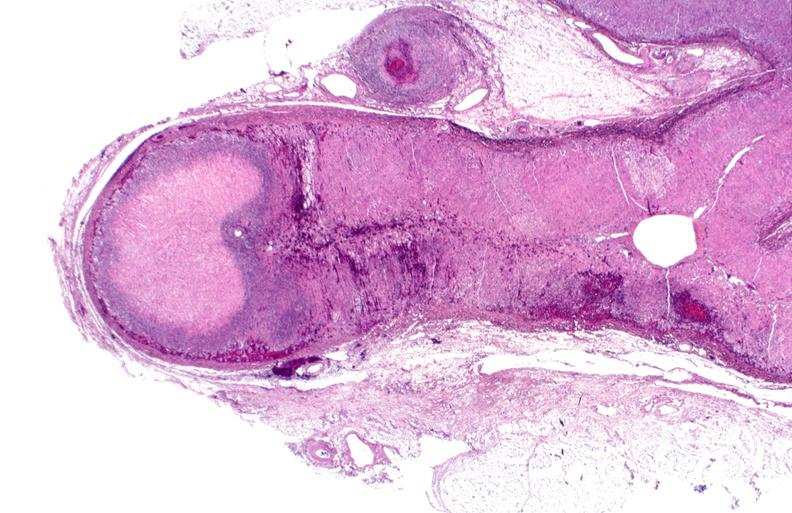does photo show adrenal, polyarteritis nodosa with infarct?
Answer the question using a single word or phrase. No 